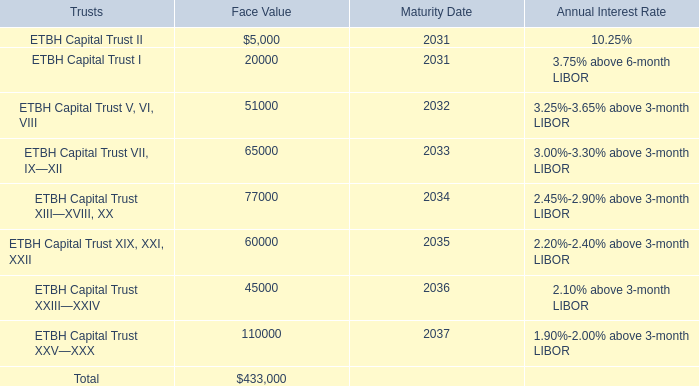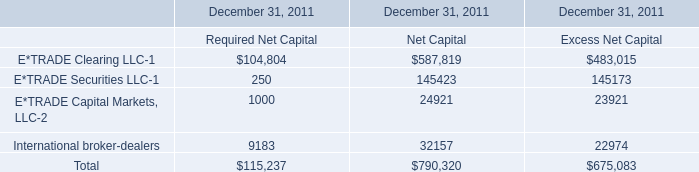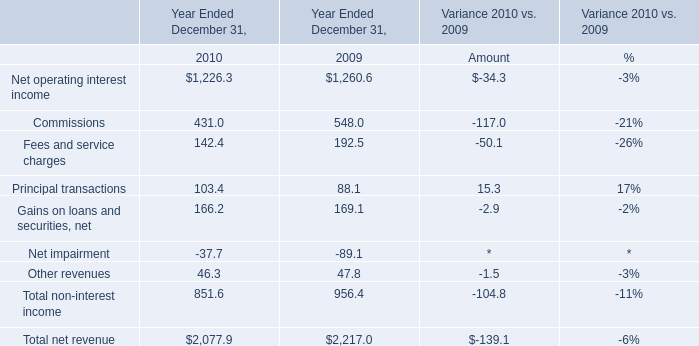as of december 31 , 2010 , what was the ratio of collateral pledged to the bank by its derivatives counterparties to overnight and other short-term borrowings 
Computations: (2.3 / 0.5)
Answer: 4.6. 